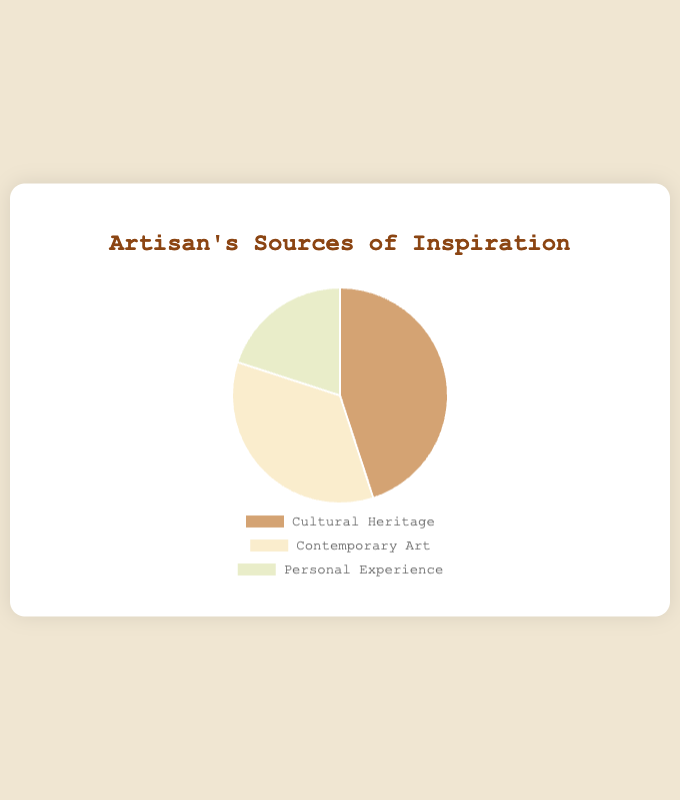Which source of inspiration has the highest percentage? Looking at the pie chart, the largest segment represents the source with the highest percentage. The segment for "Cultural Heritage" visually stands out as the largest portion.
Answer: Cultural Heritage Which source has the least percentage of inspiration? Observing the pie chart, the smallest segment indicates the source with the least percentage. "Personal Experience" occupies the smallest area in the chart.
Answer: Personal Experience How much larger is the "Cultural Heritage" segment compared to the "Personal Experience" segment? The "Cultural Heritage" segment is 45% and the "Personal Experience" segment is 20%. Subtract 20% from 45% to find the difference: 45% - 20% = 25%.
Answer: 25% What is the combined percentage of "Cultural Heritage" and "Contemporary Art"? To find the combined percentage, add the percentages of "Cultural Heritage" and "Contemporary Art": 45% + 35% = 80%.
Answer: 80% Is the "Contemporary Art" segment larger than "Personal Experience"? Compare the percentages shown in the pie chart: "Contemporary Art" is 35% and "Personal Experience" is 20%. Since 35% is greater than 20%, "Contemporary Art" is indeed larger.
Answer: Yes What color represents the "Cultural Heritage" segment? From the visual attributes of the pie chart, the segment labeled "Cultural Heritage" is colored in a shade that appears to be a light brown or tan.
Answer: Light brown/tan What is the percentage difference between the largest and smallest segments? The largest segment is "Cultural Heritage" at 45% and the smallest is "Personal Experience" at 20%. Subtract the smallest percentage from the largest: 45% - 20% = 25%.
Answer: 25% Which inspiration source has a 35% share? Directly refer to the pie chart where each segment has its label and percentage indicated. The segment "Contemporary Art" shows a 35% share.
Answer: Contemporary Art If you combine "Personal Experience" and "Contemporary Art", do they make up more or less than "Cultural Heritage"? Add the percentages of "Personal Experience" (20%) and "Contemporary Art" (35%) to get the sum: 20% + 35% = 55%. Since 55% is more than "Cultural Heritage’s" 45%, their combined total is higher.
Answer: More What percentage of your inspiration comes from non-Cultural Heritage sources? Add the percentages of "Contemporary Art" and "Personal Experience": 35% + 20% = 55%.
Answer: 55% 